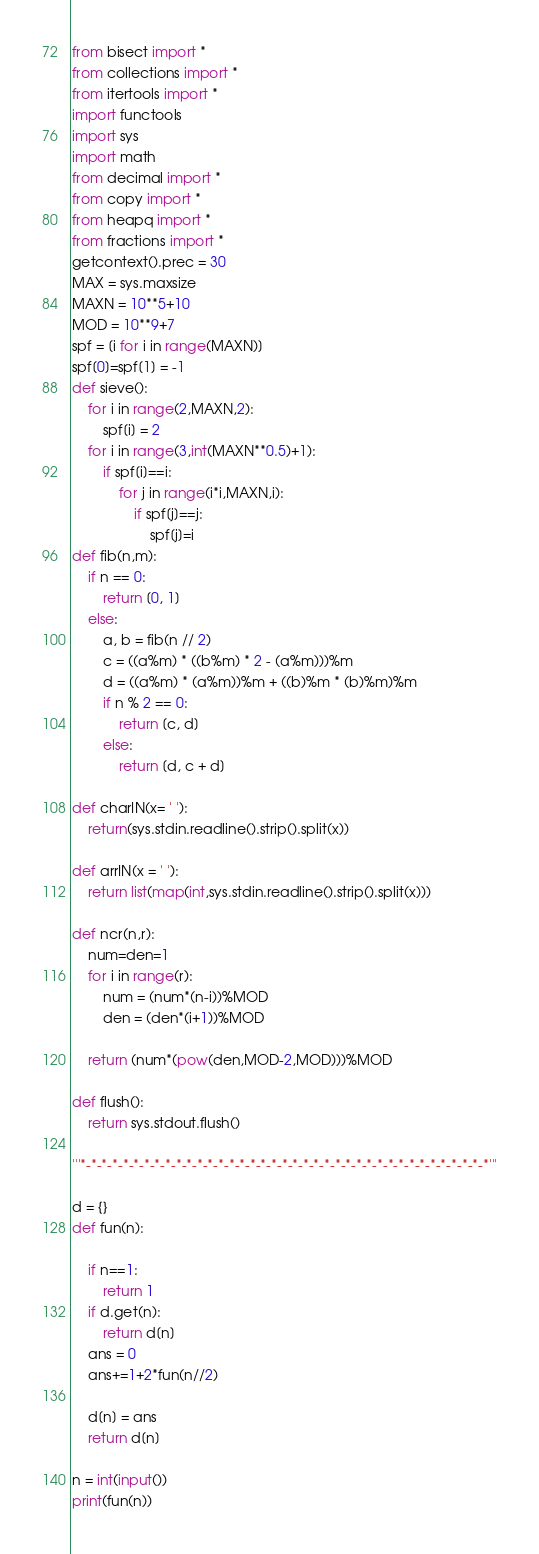Convert code to text. <code><loc_0><loc_0><loc_500><loc_500><_Python_>from bisect import *
from collections import *
from itertools import *
import functools
import sys
import math
from decimal import *
from copy import *
from heapq import *
from fractions import *
getcontext().prec = 30
MAX = sys.maxsize
MAXN = 10**5+10
MOD = 10**9+7
spf = [i for i in range(MAXN)]
spf[0]=spf[1] = -1
def sieve():
    for i in range(2,MAXN,2):
        spf[i] = 2
    for i in range(3,int(MAXN**0.5)+1):
        if spf[i]==i:
            for j in range(i*i,MAXN,i):
                if spf[j]==j:
                    spf[j]=i
def fib(n,m):
    if n == 0:
        return [0, 1]
    else:
        a, b = fib(n // 2)
        c = ((a%m) * ((b%m) * 2 - (a%m)))%m
        d = ((a%m) * (a%m))%m + ((b)%m * (b)%m)%m
        if n % 2 == 0:
            return [c, d]
        else:
            return [d, c + d]

def charIN(x= ' '):
    return(sys.stdin.readline().strip().split(x))

def arrIN(x = ' '):
    return list(map(int,sys.stdin.readline().strip().split(x)))

def ncr(n,r):
    num=den=1
    for i in range(r):
        num = (num*(n-i))%MOD
        den = (den*(i+1))%MOD

    return (num*(pow(den,MOD-2,MOD)))%MOD

def flush():
    return sys.stdout.flush()

'''*-*-*-*-*-*-*-*-*-*-*-*-*-*-*-*-*-*-*-*-*-*-*-*-*-*-*-*-*-*-*-*-*-*-*-*-*-*-*'''

d = {}
def fun(n):

    if n==1:
        return 1
    if d.get(n):
        return d[n]
    ans = 0
    ans+=1+2*fun(n//2)

    d[n] = ans
    return d[n]

n = int(input())
print(fun(n))</code> 